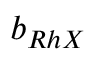<formula> <loc_0><loc_0><loc_500><loc_500>b _ { R h X }</formula> 